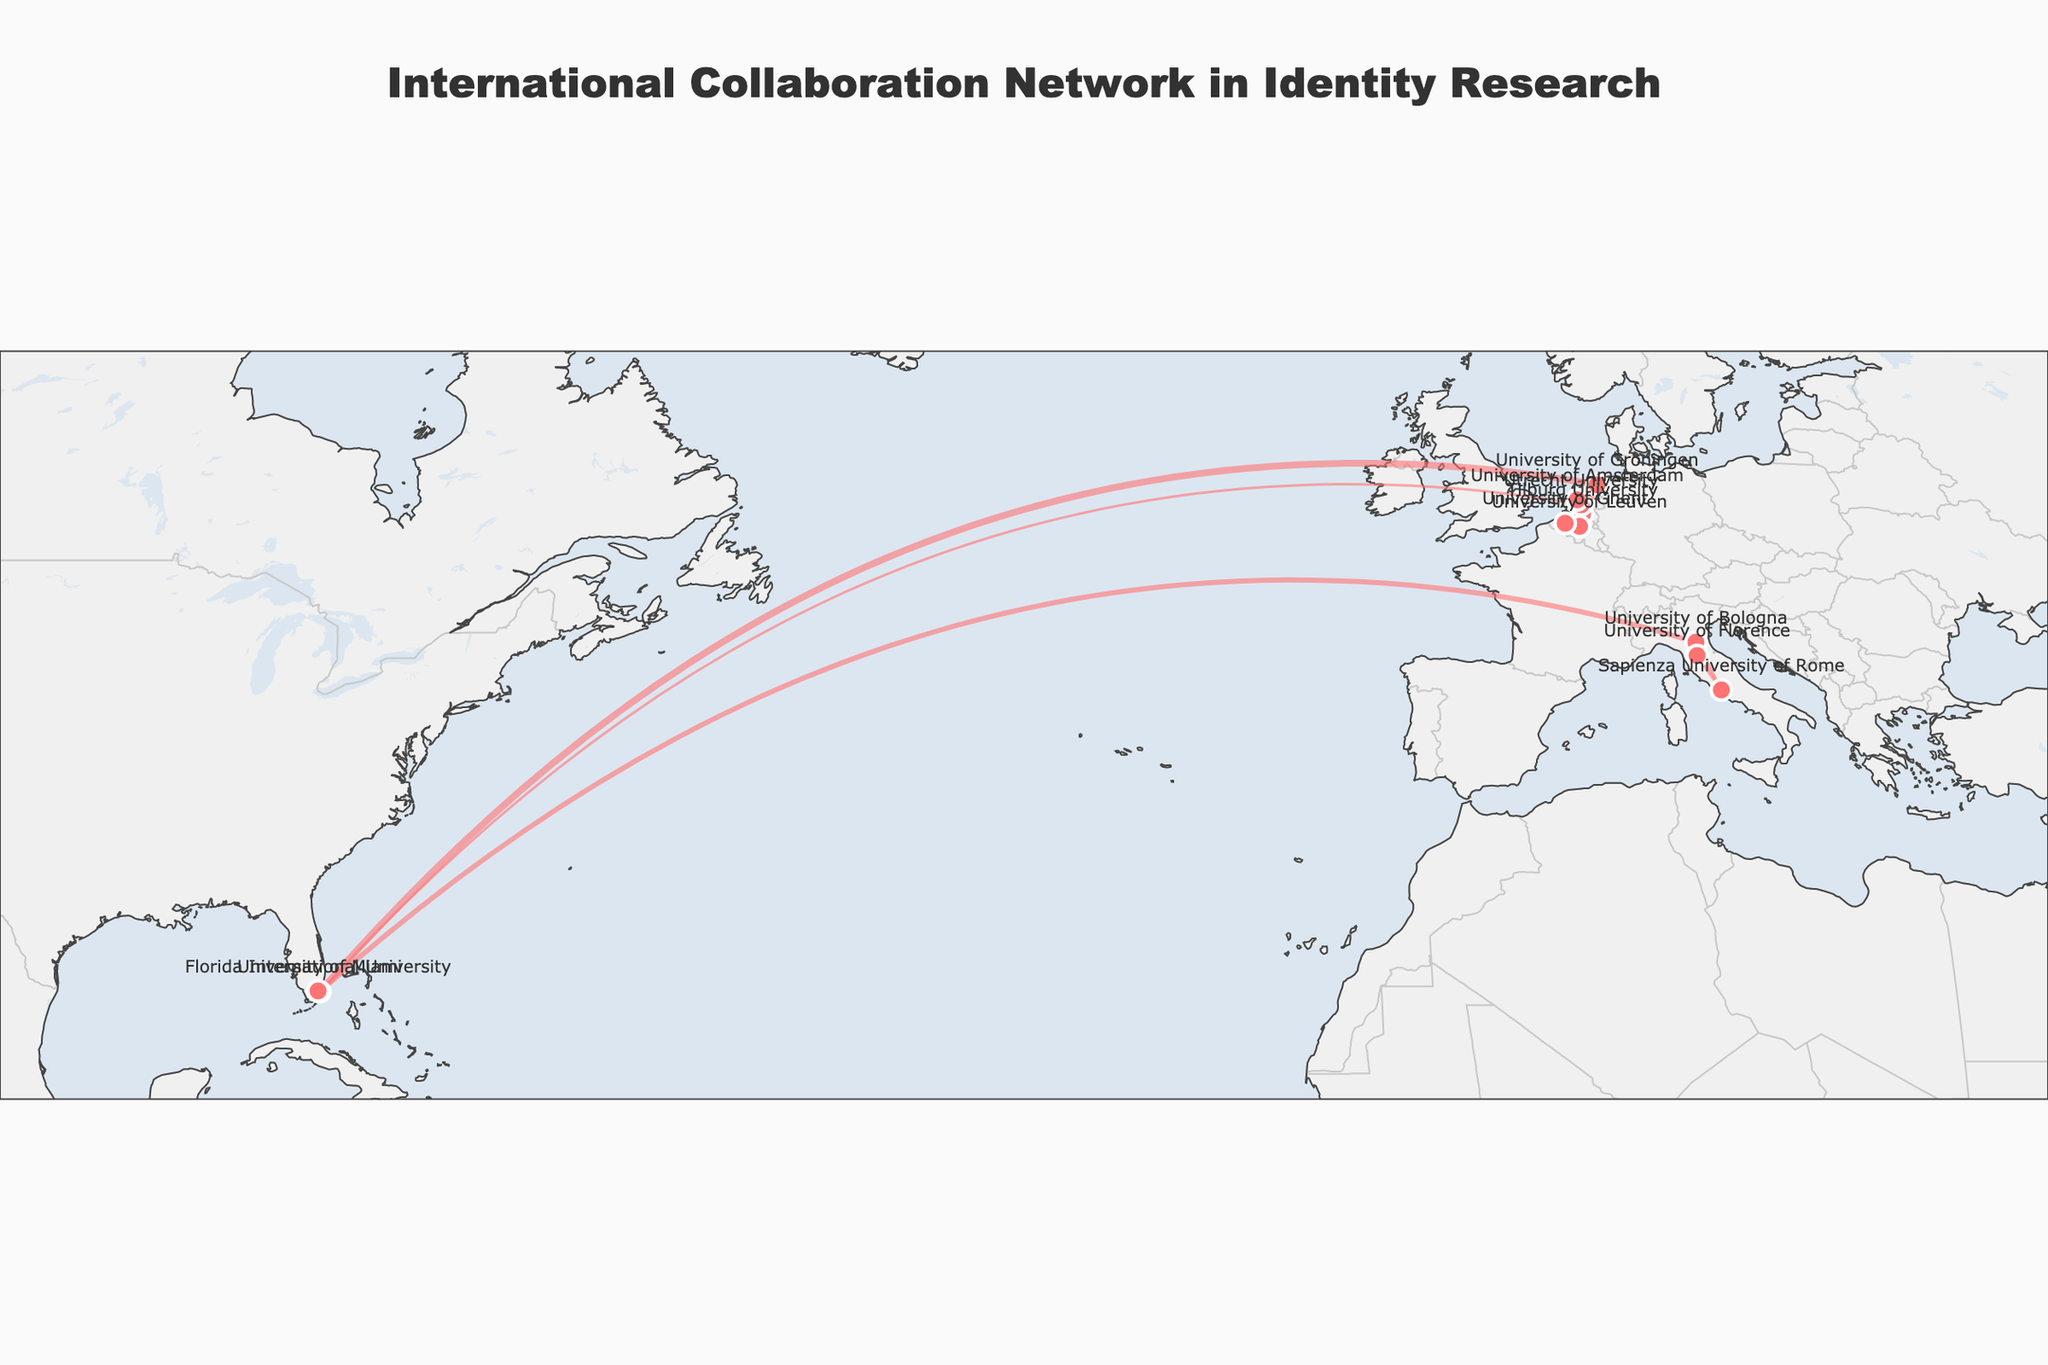How many institutions are represented in the collaboration network? There are markers placed for each unique institution on the map. By observing and counting these unique markers, we find there are 9 institutions represented.
Answer: 9 What is the title of the figure? The title is prominently displayed at the top center of the figure. It reads "International Collaboration Network in Identity Research".
Answer: International Collaboration Network in Identity Research Which two institutions have the strongest collaboration? By examining the width of the lines connecting the institutions, the strongest connection is depicted by the thickest line. This is between the University of Miami and the University of Groningen with a collaboration strength of 0.8.
Answer: University of Miami and University of Groningen Which institution appears most frequently in the collaborations? The University of Miami appears most frequently as it is connected to four different institutions: University of Groningen, University of Bologna, Utrecht University, and Florida International University.
Answer: University of Miami Which two European institutions have the closest geographical proximity based on the map? By observing the geographical locations and distances between institutions, Utrecht University and the University of Amsterdam appear closest to each other.
Answer: Utrecht University and University of Amsterdam What is the collaboration strength between the University of Groningen and Tilburg University? The line connecting the University of Groningen and Tilburg University indicates their collaboration strength, which is represented visually by the line width. It can be observed that the strength is 0.7.
Answer: 0.7 Which European institution is connected to the largest number of other institutions? By looking at the number of lines emanating from each European institution, the University of Groningen is connected to the University of Miami, Tilburg University, and the University of Amsterdam, making it the one with the most connections.
Answer: University of Groningen How does the collaboration strength between University of Ghent and University of Leuven compare to that between Sapienza University of Rome and University of Florence? By comparing the widths of the lines, the collaboration strength between University of Ghent and University of Leuven is 0.6, whereas between Sapienza University of Rome and University of Florence it is 0.4. Hence, the former is stronger.
Answer: Stronger How many institutions are located in Italy? Observing the geographical plots, there are markers corresponding to institutions in Italy: University of Bologna, Sapienza University of Rome, and the University of Florence. There are 3 institutions.
Answer: 3 